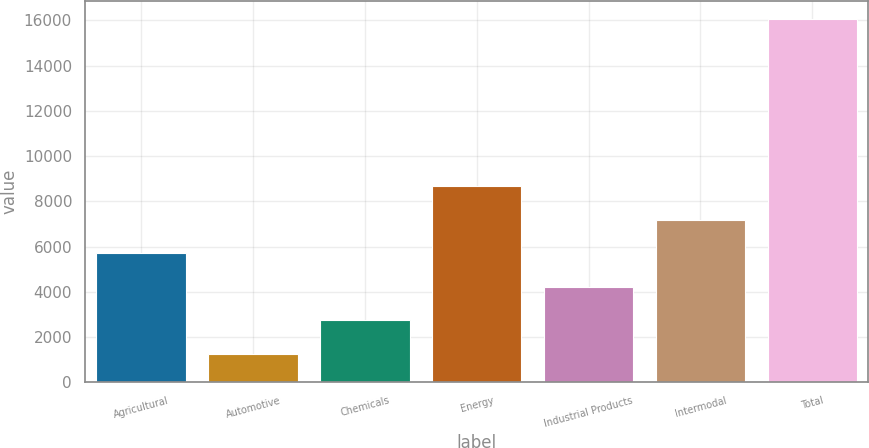<chart> <loc_0><loc_0><loc_500><loc_500><bar_chart><fcel>Agricultural<fcel>Automotive<fcel>Chemicals<fcel>Energy<fcel>Industrial Products<fcel>Intermodal<fcel>Total<nl><fcel>5710.4<fcel>1271<fcel>2750.8<fcel>8670<fcel>4230.6<fcel>7190.2<fcel>16069<nl></chart> 